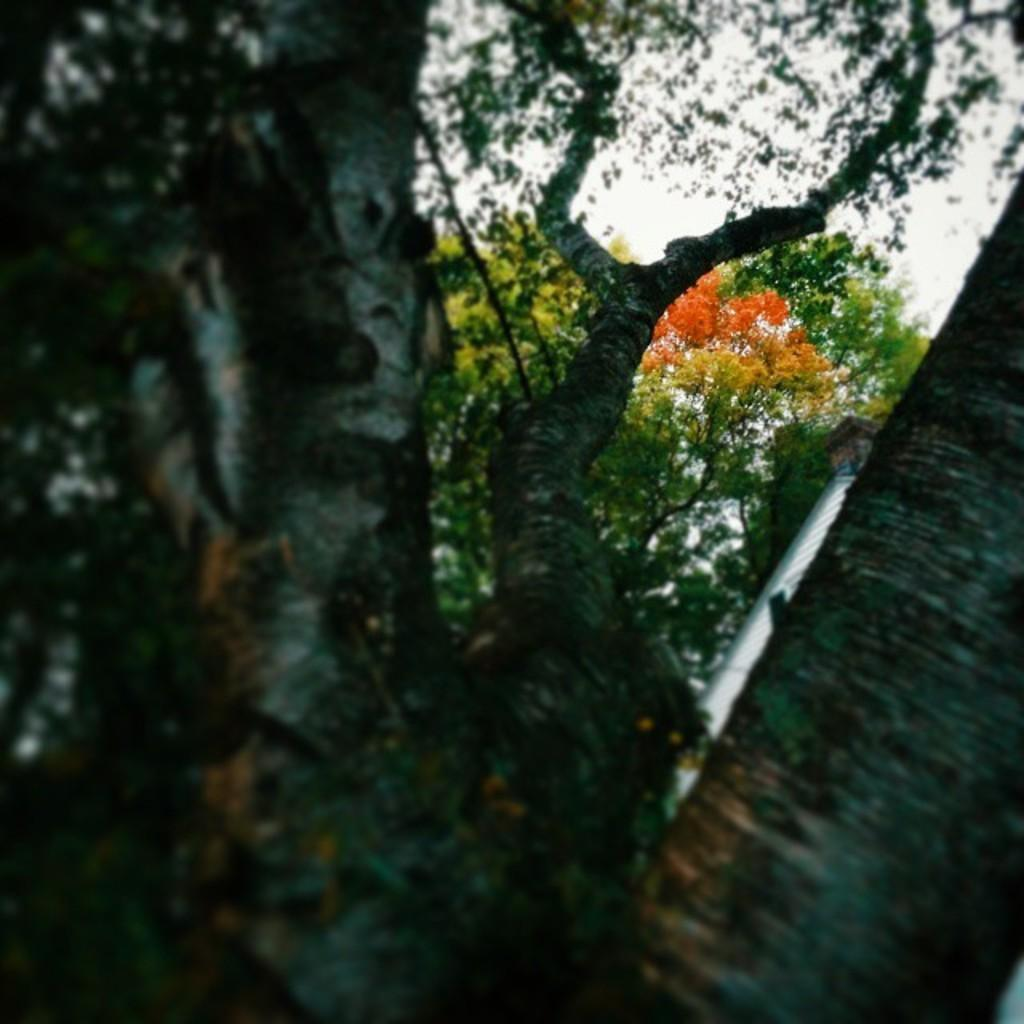What type of vegetation can be seen in the image? There are trees in the image. What is the condition of the sky in the image? The sky is cloudy in the image. What is the belief of the trees in the image? Trees do not have beliefs, as they are inanimate objects. 